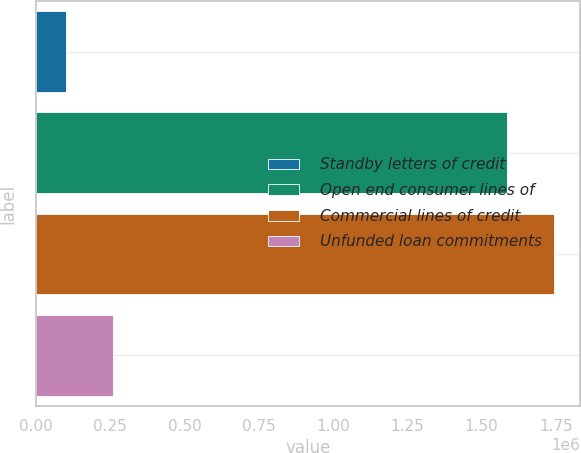Convert chart to OTSL. <chart><loc_0><loc_0><loc_500><loc_500><bar_chart><fcel>Standby letters of credit<fcel>Open end consumer lines of<fcel>Commercial lines of credit<fcel>Unfunded loan commitments<nl><fcel>100582<fcel>1.58572e+06<fcel>1.74495e+06<fcel>259813<nl></chart> 